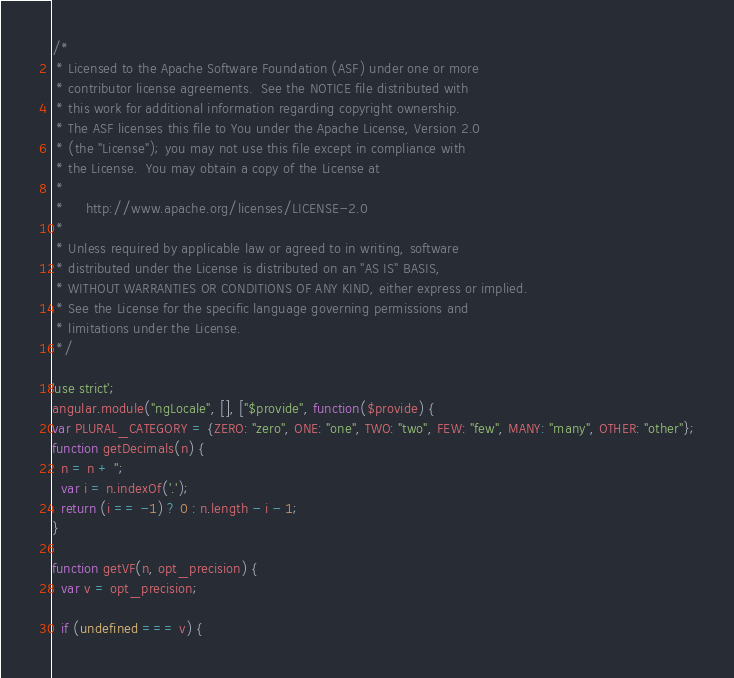Convert code to text. <code><loc_0><loc_0><loc_500><loc_500><_JavaScript_>/*
 * Licensed to the Apache Software Foundation (ASF) under one or more
 * contributor license agreements.  See the NOTICE file distributed with
 * this work for additional information regarding copyright ownership.
 * The ASF licenses this file to You under the Apache License, Version 2.0
 * (the "License"); you may not use this file except in compliance with
 * the License.  You may obtain a copy of the License at
 *
 *     http://www.apache.org/licenses/LICENSE-2.0
 *
 * Unless required by applicable law or agreed to in writing, software
 * distributed under the License is distributed on an "AS IS" BASIS,
 * WITHOUT WARRANTIES OR CONDITIONS OF ANY KIND, either express or implied.
 * See the License for the specific language governing permissions and
 * limitations under the License.
 */

'use strict';
angular.module("ngLocale", [], ["$provide", function($provide) {
var PLURAL_CATEGORY = {ZERO: "zero", ONE: "one", TWO: "two", FEW: "few", MANY: "many", OTHER: "other"};
function getDecimals(n) {
  n = n + '';
  var i = n.indexOf('.');
  return (i == -1) ? 0 : n.length - i - 1;
}

function getVF(n, opt_precision) {
  var v = opt_precision;

  if (undefined === v) {</code> 